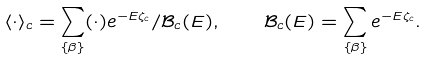Convert formula to latex. <formula><loc_0><loc_0><loc_500><loc_500>\langle \cdot \rangle _ { c } = \sum _ { \{ \beta \} } ( \cdot ) e ^ { - E \zeta _ { c } } / \mathcal { B } _ { c } ( E ) , \quad \mathcal { B } _ { c } ( E ) = \sum _ { \{ \beta \} } e ^ { - E \zeta _ { c } } .</formula> 